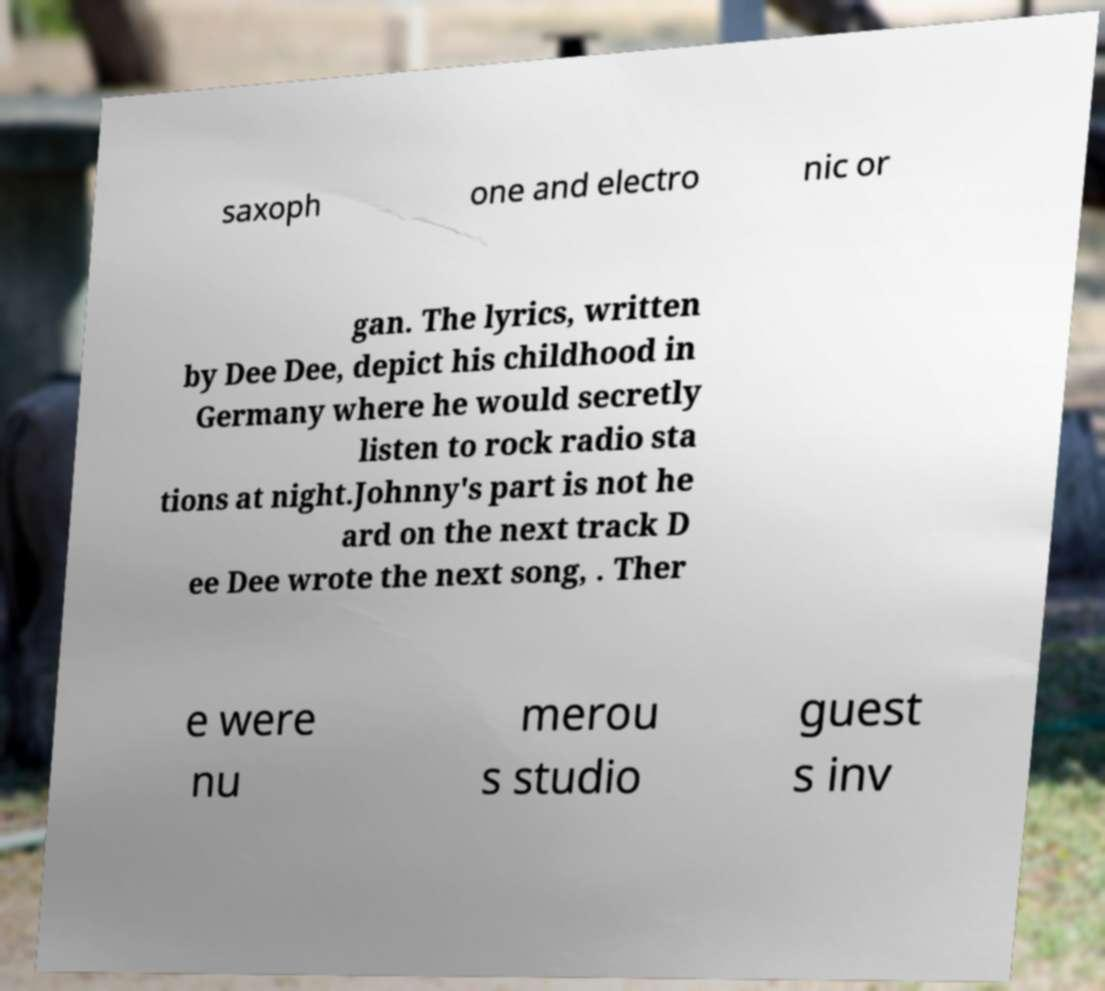What messages or text are displayed in this image? I need them in a readable, typed format. saxoph one and electro nic or gan. The lyrics, written by Dee Dee, depict his childhood in Germany where he would secretly listen to rock radio sta tions at night.Johnny's part is not he ard on the next track D ee Dee wrote the next song, . Ther e were nu merou s studio guest s inv 